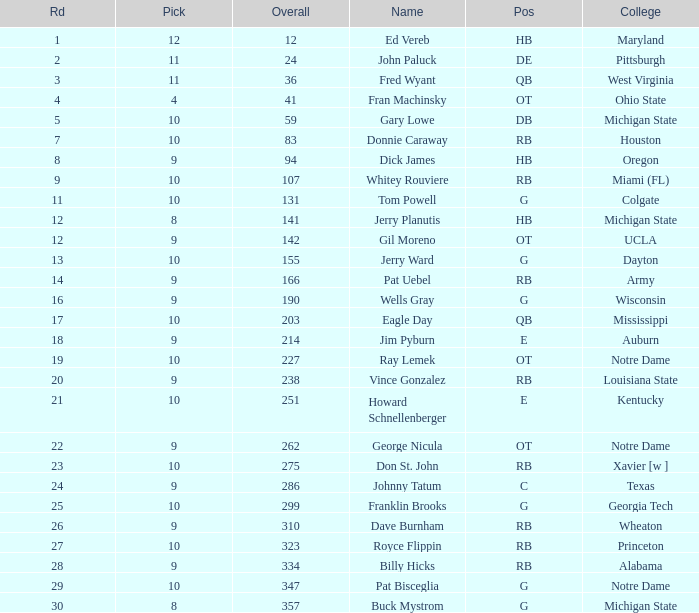Would you be able to parse every entry in this table? {'header': ['Rd', 'Pick', 'Overall', 'Name', 'Pos', 'College'], 'rows': [['1', '12', '12', 'Ed Vereb', 'HB', 'Maryland'], ['2', '11', '24', 'John Paluck', 'DE', 'Pittsburgh'], ['3', '11', '36', 'Fred Wyant', 'QB', 'West Virginia'], ['4', '4', '41', 'Fran Machinsky', 'OT', 'Ohio State'], ['5', '10', '59', 'Gary Lowe', 'DB', 'Michigan State'], ['7', '10', '83', 'Donnie Caraway', 'RB', 'Houston'], ['8', '9', '94', 'Dick James', 'HB', 'Oregon'], ['9', '10', '107', 'Whitey Rouviere', 'RB', 'Miami (FL)'], ['11', '10', '131', 'Tom Powell', 'G', 'Colgate'], ['12', '8', '141', 'Jerry Planutis', 'HB', 'Michigan State'], ['12', '9', '142', 'Gil Moreno', 'OT', 'UCLA'], ['13', '10', '155', 'Jerry Ward', 'G', 'Dayton'], ['14', '9', '166', 'Pat Uebel', 'RB', 'Army'], ['16', '9', '190', 'Wells Gray', 'G', 'Wisconsin'], ['17', '10', '203', 'Eagle Day', 'QB', 'Mississippi'], ['18', '9', '214', 'Jim Pyburn', 'E', 'Auburn'], ['19', '10', '227', 'Ray Lemek', 'OT', 'Notre Dame'], ['20', '9', '238', 'Vince Gonzalez', 'RB', 'Louisiana State'], ['21', '10', '251', 'Howard Schnellenberger', 'E', 'Kentucky'], ['22', '9', '262', 'George Nicula', 'OT', 'Notre Dame'], ['23', '10', '275', 'Don St. John', 'RB', 'Xavier [w ]'], ['24', '9', '286', 'Johnny Tatum', 'C', 'Texas'], ['25', '10', '299', 'Franklin Brooks', 'G', 'Georgia Tech'], ['26', '9', '310', 'Dave Burnham', 'RB', 'Wheaton'], ['27', '10', '323', 'Royce Flippin', 'RB', 'Princeton'], ['28', '9', '334', 'Billy Hicks', 'RB', 'Alabama'], ['29', '10', '347', 'Pat Bisceglia', 'G', 'Notre Dame'], ['30', '8', '357', 'Buck Mystrom', 'G', 'Michigan State']]} What is the total number of overall picks that were after pick 9 and went to Auburn College? 0.0. 